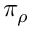<formula> <loc_0><loc_0><loc_500><loc_500>\pi _ { \rho }</formula> 